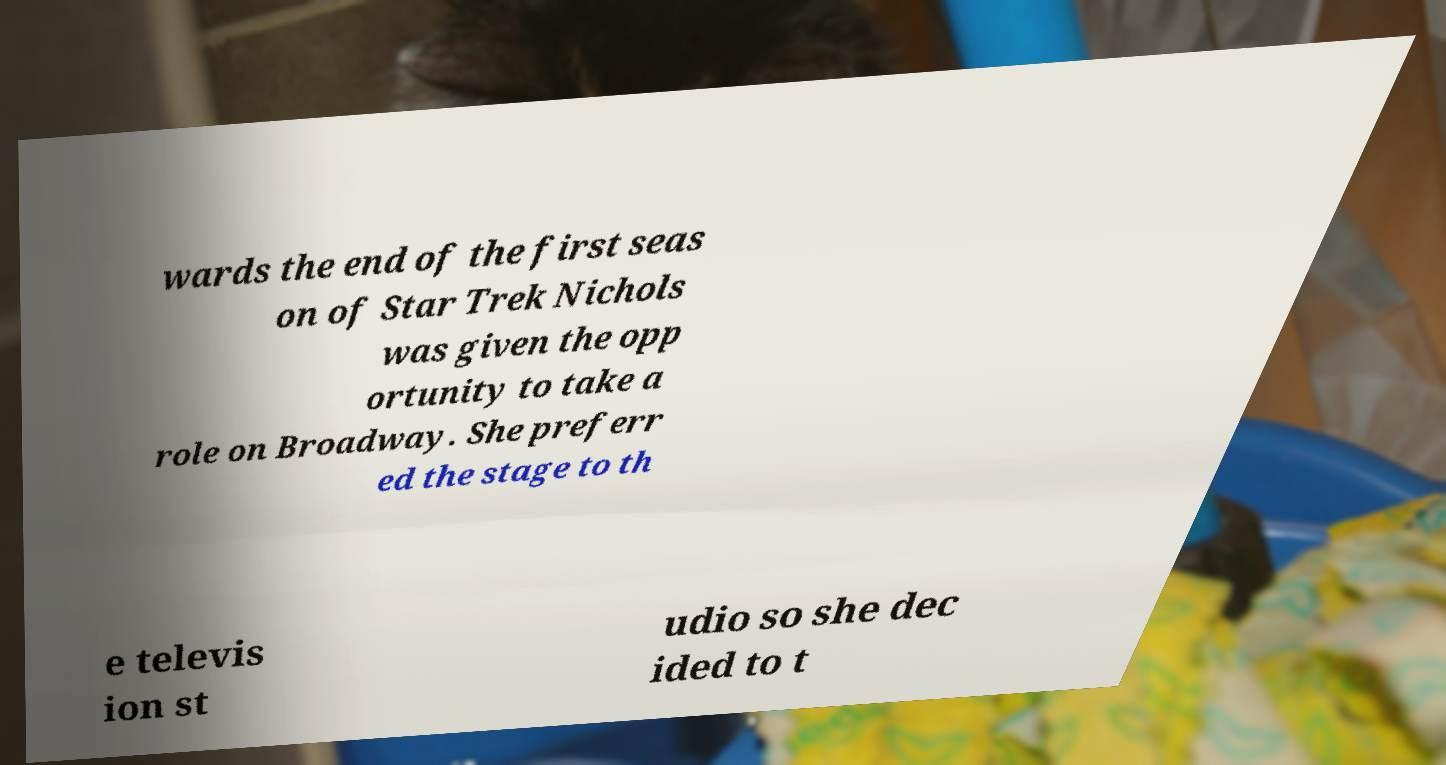I need the written content from this picture converted into text. Can you do that? wards the end of the first seas on of Star Trek Nichols was given the opp ortunity to take a role on Broadway. She preferr ed the stage to th e televis ion st udio so she dec ided to t 